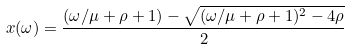Convert formula to latex. <formula><loc_0><loc_0><loc_500><loc_500>x ( \omega ) = \frac { ( \omega / \mu + \rho + 1 ) - \sqrt { ( \omega / \mu + \rho + 1 ) ^ { 2 } - 4 \rho } } { 2 }</formula> 